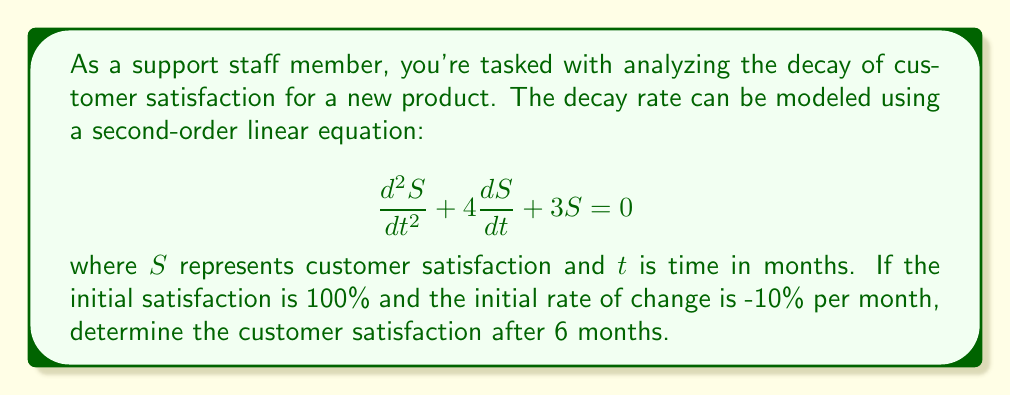Provide a solution to this math problem. To solve this problem, we need to follow these steps:

1) The general solution to this second-order linear equation is:
   $$S(t) = c_1e^{-t} + c_2e^{-3t}$$

2) We need to find $c_1$ and $c_2$ using the initial conditions:
   - $S(0) = 100$ (initial satisfaction is 100%)
   - $S'(0) = -10$ (initial rate of change is -10% per month)

3) Using the first condition:
   $$S(0) = c_1 + c_2 = 100$$

4) For the second condition, we differentiate $S(t)$:
   $$S'(t) = -c_1e^{-t} - 3c_2e^{-3t}$$
   $$S'(0) = -c_1 - 3c_2 = -10$$

5) Now we have a system of equations:
   $$c_1 + c_2 = 100$$
   $$c_1 + 3c_2 = 10$$

6) Subtracting the second equation from the first:
   $$-2c_2 = 90$$
   $$c_2 = -45$$

7) Substituting back:
   $$c_1 + (-45) = 100$$
   $$c_1 = 145$$

8) Our solution is:
   $$S(t) = 145e^{-t} - 45e^{-3t}$$

9) To find satisfaction after 6 months, we calculate $S(6)$:
   $$S(6) = 145e^{-6} - 45e^{-18}$$
   $$\approx 145(0.00248) - 45(1.52\times10^{-8})$$
   $$\approx 0.3596 - 0.0000007$$
   $$\approx 0.3596$$

10) Converting to a percentage:
    $$0.3596 \times 100\% \approx 35.96\%$$
Answer: The customer satisfaction after 6 months is approximately 35.96%. 